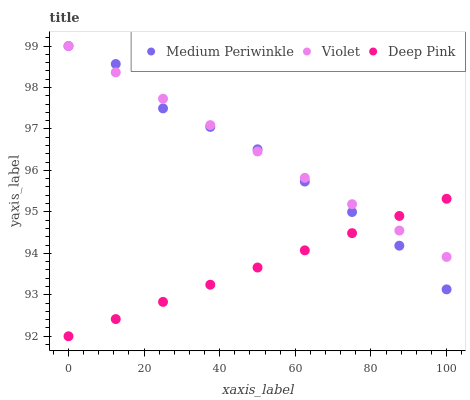Does Deep Pink have the minimum area under the curve?
Answer yes or no. Yes. Does Violet have the maximum area under the curve?
Answer yes or no. Yes. Does Medium Periwinkle have the minimum area under the curve?
Answer yes or no. No. Does Medium Periwinkle have the maximum area under the curve?
Answer yes or no. No. Is Deep Pink the smoothest?
Answer yes or no. Yes. Is Medium Periwinkle the roughest?
Answer yes or no. Yes. Is Violet the smoothest?
Answer yes or no. No. Is Violet the roughest?
Answer yes or no. No. Does Deep Pink have the lowest value?
Answer yes or no. Yes. Does Medium Periwinkle have the lowest value?
Answer yes or no. No. Does Violet have the highest value?
Answer yes or no. Yes. Does Violet intersect Deep Pink?
Answer yes or no. Yes. Is Violet less than Deep Pink?
Answer yes or no. No. Is Violet greater than Deep Pink?
Answer yes or no. No. 